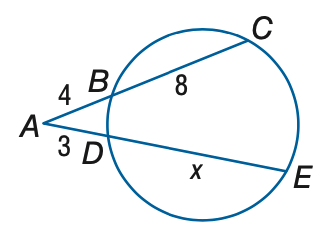Question: Find x to the nearest tenth.
Choices:
A. 10
B. 11
C. 12
D. 13
Answer with the letter. Answer: D 